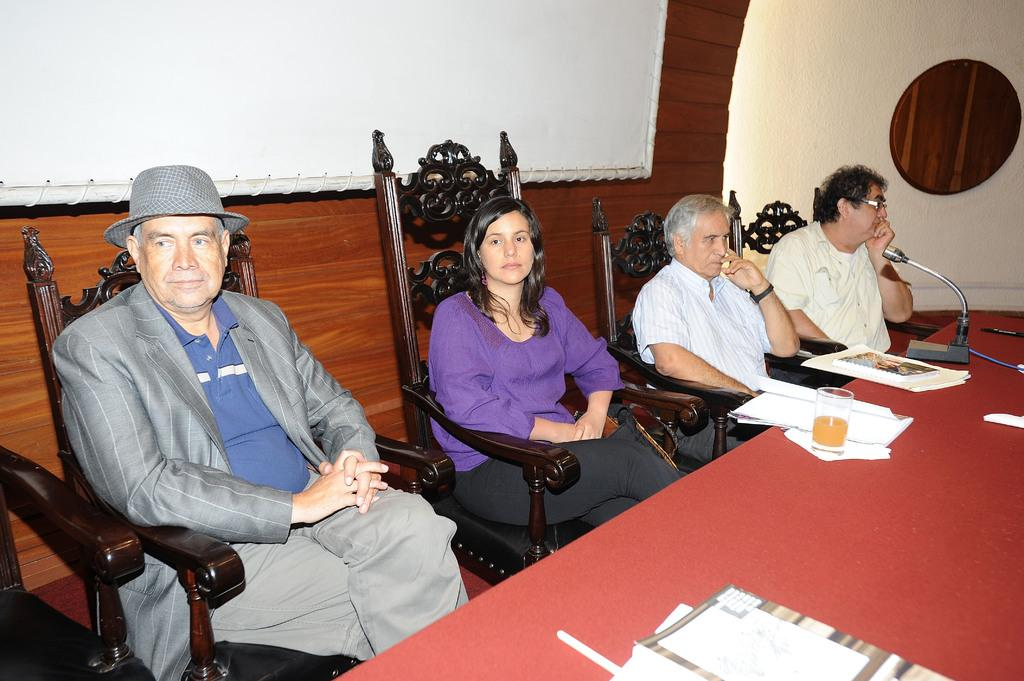What is the man doing in the image? The man is sitting on a chair on the left side of the image. What is the man wearing in the image? The man is wearing a coat and a hat. Who is sitting beside the man? There is a woman sitting on a chair beside the man. What is the woman wearing in the image? The woman is wearing a purple top. What can be seen on the table in the image? There is a glass on the table. What type of alarm is going off in the image? There is no alarm present in the image. Are there any police officers visible in the image? There are no police officers present in the image. Can you see a baby in the image? There is no baby present in the image. 